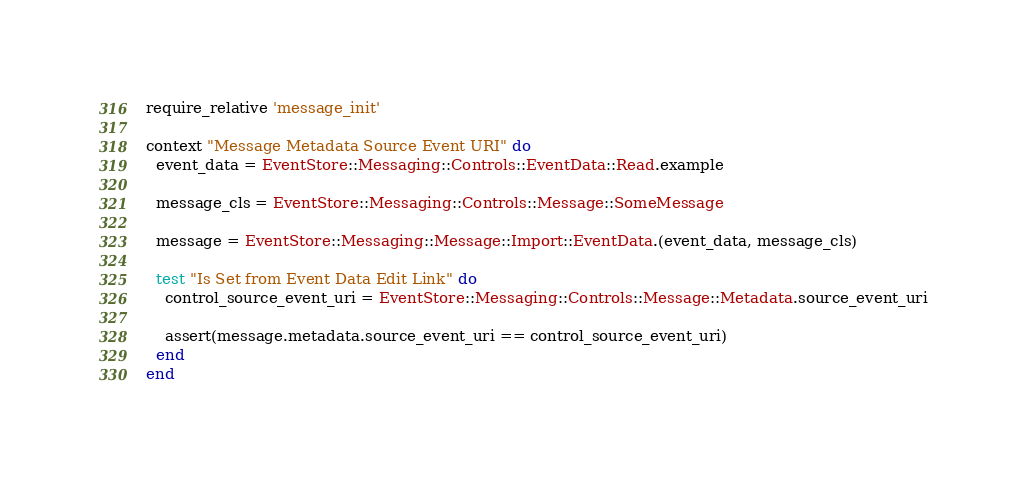<code> <loc_0><loc_0><loc_500><loc_500><_Ruby_>require_relative 'message_init'

context "Message Metadata Source Event URI" do
  event_data = EventStore::Messaging::Controls::EventData::Read.example

  message_cls = EventStore::Messaging::Controls::Message::SomeMessage

  message = EventStore::Messaging::Message::Import::EventData.(event_data, message_cls)

  test "Is Set from Event Data Edit Link" do
    control_source_event_uri = EventStore::Messaging::Controls::Message::Metadata.source_event_uri

    assert(message.metadata.source_event_uri == control_source_event_uri)
  end
end
</code> 